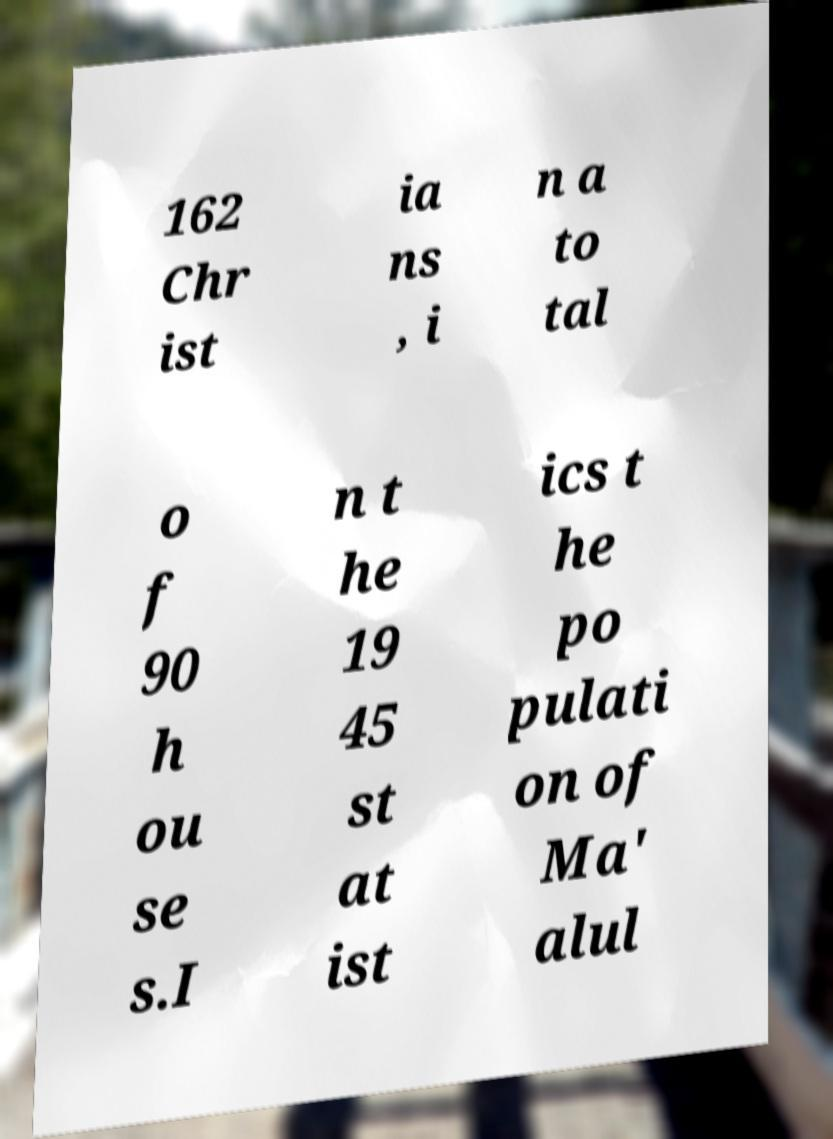Please read and relay the text visible in this image. What does it say? 162 Chr ist ia ns , i n a to tal o f 90 h ou se s.I n t he 19 45 st at ist ics t he po pulati on of Ma' alul 